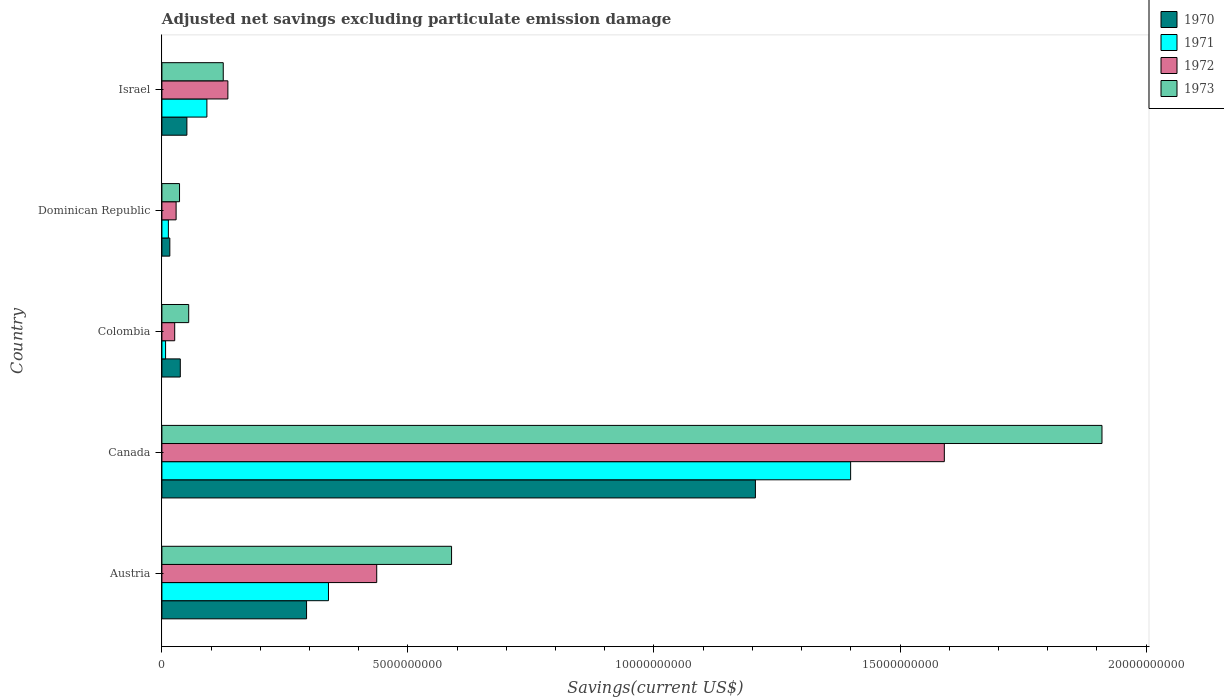Are the number of bars per tick equal to the number of legend labels?
Give a very brief answer. Yes. Are the number of bars on each tick of the Y-axis equal?
Offer a terse response. Yes. How many bars are there on the 5th tick from the top?
Provide a succinct answer. 4. What is the label of the 3rd group of bars from the top?
Offer a terse response. Colombia. What is the adjusted net savings in 1971 in Israel?
Offer a terse response. 9.14e+08. Across all countries, what is the maximum adjusted net savings in 1970?
Keep it short and to the point. 1.21e+1. Across all countries, what is the minimum adjusted net savings in 1970?
Your answer should be compact. 1.61e+08. What is the total adjusted net savings in 1971 in the graph?
Make the answer very short. 1.85e+1. What is the difference between the adjusted net savings in 1973 in Austria and that in Canada?
Make the answer very short. -1.32e+1. What is the difference between the adjusted net savings in 1970 in Colombia and the adjusted net savings in 1972 in Austria?
Your answer should be compact. -3.99e+09. What is the average adjusted net savings in 1970 per country?
Your response must be concise. 3.21e+09. What is the difference between the adjusted net savings in 1972 and adjusted net savings in 1971 in Israel?
Keep it short and to the point. 4.27e+08. In how many countries, is the adjusted net savings in 1972 greater than 12000000000 US$?
Provide a succinct answer. 1. What is the ratio of the adjusted net savings in 1972 in Dominican Republic to that in Israel?
Offer a very short reply. 0.22. Is the adjusted net savings in 1973 in Canada less than that in Israel?
Make the answer very short. No. Is the difference between the adjusted net savings in 1972 in Canada and Israel greater than the difference between the adjusted net savings in 1971 in Canada and Israel?
Provide a short and direct response. Yes. What is the difference between the highest and the second highest adjusted net savings in 1973?
Ensure brevity in your answer.  1.32e+1. What is the difference between the highest and the lowest adjusted net savings in 1973?
Offer a very short reply. 1.87e+1. In how many countries, is the adjusted net savings in 1970 greater than the average adjusted net savings in 1970 taken over all countries?
Offer a very short reply. 1. Is it the case that in every country, the sum of the adjusted net savings in 1971 and adjusted net savings in 1970 is greater than the sum of adjusted net savings in 1972 and adjusted net savings in 1973?
Your answer should be compact. No. What is the difference between two consecutive major ticks on the X-axis?
Your response must be concise. 5.00e+09. Does the graph contain any zero values?
Give a very brief answer. No. Where does the legend appear in the graph?
Provide a short and direct response. Top right. How are the legend labels stacked?
Offer a very short reply. Vertical. What is the title of the graph?
Provide a succinct answer. Adjusted net savings excluding particulate emission damage. What is the label or title of the X-axis?
Make the answer very short. Savings(current US$). What is the Savings(current US$) in 1970 in Austria?
Your answer should be very brief. 2.94e+09. What is the Savings(current US$) in 1971 in Austria?
Offer a terse response. 3.38e+09. What is the Savings(current US$) of 1972 in Austria?
Offer a terse response. 4.37e+09. What is the Savings(current US$) of 1973 in Austria?
Keep it short and to the point. 5.89e+09. What is the Savings(current US$) in 1970 in Canada?
Keep it short and to the point. 1.21e+1. What is the Savings(current US$) in 1971 in Canada?
Your answer should be compact. 1.40e+1. What is the Savings(current US$) in 1972 in Canada?
Ensure brevity in your answer.  1.59e+1. What is the Savings(current US$) of 1973 in Canada?
Give a very brief answer. 1.91e+1. What is the Savings(current US$) in 1970 in Colombia?
Make the answer very short. 3.74e+08. What is the Savings(current US$) in 1971 in Colombia?
Offer a terse response. 7.46e+07. What is the Savings(current US$) in 1972 in Colombia?
Ensure brevity in your answer.  2.60e+08. What is the Savings(current US$) of 1973 in Colombia?
Provide a short and direct response. 5.45e+08. What is the Savings(current US$) of 1970 in Dominican Republic?
Make the answer very short. 1.61e+08. What is the Savings(current US$) of 1971 in Dominican Republic?
Your answer should be very brief. 1.32e+08. What is the Savings(current US$) of 1972 in Dominican Republic?
Your answer should be compact. 2.89e+08. What is the Savings(current US$) of 1973 in Dominican Republic?
Your answer should be compact. 3.58e+08. What is the Savings(current US$) of 1970 in Israel?
Provide a short and direct response. 5.08e+08. What is the Savings(current US$) in 1971 in Israel?
Provide a succinct answer. 9.14e+08. What is the Savings(current US$) of 1972 in Israel?
Your response must be concise. 1.34e+09. What is the Savings(current US$) in 1973 in Israel?
Your response must be concise. 1.25e+09. Across all countries, what is the maximum Savings(current US$) in 1970?
Your answer should be compact. 1.21e+1. Across all countries, what is the maximum Savings(current US$) of 1971?
Your answer should be very brief. 1.40e+1. Across all countries, what is the maximum Savings(current US$) of 1972?
Your answer should be compact. 1.59e+1. Across all countries, what is the maximum Savings(current US$) of 1973?
Your response must be concise. 1.91e+1. Across all countries, what is the minimum Savings(current US$) of 1970?
Keep it short and to the point. 1.61e+08. Across all countries, what is the minimum Savings(current US$) of 1971?
Give a very brief answer. 7.46e+07. Across all countries, what is the minimum Savings(current US$) in 1972?
Offer a very short reply. 2.60e+08. Across all countries, what is the minimum Savings(current US$) in 1973?
Ensure brevity in your answer.  3.58e+08. What is the total Savings(current US$) in 1970 in the graph?
Keep it short and to the point. 1.60e+1. What is the total Savings(current US$) of 1971 in the graph?
Give a very brief answer. 1.85e+1. What is the total Savings(current US$) in 1972 in the graph?
Your answer should be very brief. 2.22e+1. What is the total Savings(current US$) in 1973 in the graph?
Offer a terse response. 2.71e+1. What is the difference between the Savings(current US$) in 1970 in Austria and that in Canada?
Offer a terse response. -9.12e+09. What is the difference between the Savings(current US$) in 1971 in Austria and that in Canada?
Your answer should be compact. -1.06e+1. What is the difference between the Savings(current US$) of 1972 in Austria and that in Canada?
Offer a very short reply. -1.15e+1. What is the difference between the Savings(current US$) of 1973 in Austria and that in Canada?
Give a very brief answer. -1.32e+1. What is the difference between the Savings(current US$) in 1970 in Austria and that in Colombia?
Your response must be concise. 2.57e+09. What is the difference between the Savings(current US$) of 1971 in Austria and that in Colombia?
Your answer should be very brief. 3.31e+09. What is the difference between the Savings(current US$) in 1972 in Austria and that in Colombia?
Offer a terse response. 4.11e+09. What is the difference between the Savings(current US$) in 1973 in Austria and that in Colombia?
Provide a short and direct response. 5.34e+09. What is the difference between the Savings(current US$) of 1970 in Austria and that in Dominican Republic?
Your answer should be very brief. 2.78e+09. What is the difference between the Savings(current US$) of 1971 in Austria and that in Dominican Republic?
Make the answer very short. 3.25e+09. What is the difference between the Savings(current US$) in 1972 in Austria and that in Dominican Republic?
Your answer should be compact. 4.08e+09. What is the difference between the Savings(current US$) of 1973 in Austria and that in Dominican Republic?
Make the answer very short. 5.53e+09. What is the difference between the Savings(current US$) of 1970 in Austria and that in Israel?
Your answer should be very brief. 2.43e+09. What is the difference between the Savings(current US$) in 1971 in Austria and that in Israel?
Offer a terse response. 2.47e+09. What is the difference between the Savings(current US$) of 1972 in Austria and that in Israel?
Offer a terse response. 3.02e+09. What is the difference between the Savings(current US$) of 1973 in Austria and that in Israel?
Your answer should be compact. 4.64e+09. What is the difference between the Savings(current US$) of 1970 in Canada and that in Colombia?
Your answer should be very brief. 1.17e+1. What is the difference between the Savings(current US$) of 1971 in Canada and that in Colombia?
Provide a short and direct response. 1.39e+1. What is the difference between the Savings(current US$) in 1972 in Canada and that in Colombia?
Provide a short and direct response. 1.56e+1. What is the difference between the Savings(current US$) of 1973 in Canada and that in Colombia?
Keep it short and to the point. 1.86e+1. What is the difference between the Savings(current US$) of 1970 in Canada and that in Dominican Republic?
Provide a succinct answer. 1.19e+1. What is the difference between the Savings(current US$) of 1971 in Canada and that in Dominican Republic?
Provide a succinct answer. 1.39e+1. What is the difference between the Savings(current US$) of 1972 in Canada and that in Dominican Republic?
Your response must be concise. 1.56e+1. What is the difference between the Savings(current US$) of 1973 in Canada and that in Dominican Republic?
Ensure brevity in your answer.  1.87e+1. What is the difference between the Savings(current US$) of 1970 in Canada and that in Israel?
Keep it short and to the point. 1.16e+1. What is the difference between the Savings(current US$) in 1971 in Canada and that in Israel?
Offer a very short reply. 1.31e+1. What is the difference between the Savings(current US$) of 1972 in Canada and that in Israel?
Ensure brevity in your answer.  1.46e+1. What is the difference between the Savings(current US$) of 1973 in Canada and that in Israel?
Offer a terse response. 1.79e+1. What is the difference between the Savings(current US$) of 1970 in Colombia and that in Dominican Republic?
Make the answer very short. 2.13e+08. What is the difference between the Savings(current US$) of 1971 in Colombia and that in Dominican Republic?
Offer a very short reply. -5.69e+07. What is the difference between the Savings(current US$) in 1972 in Colombia and that in Dominican Republic?
Keep it short and to the point. -2.84e+07. What is the difference between the Savings(current US$) in 1973 in Colombia and that in Dominican Republic?
Ensure brevity in your answer.  1.87e+08. What is the difference between the Savings(current US$) of 1970 in Colombia and that in Israel?
Provide a succinct answer. -1.34e+08. What is the difference between the Savings(current US$) in 1971 in Colombia and that in Israel?
Give a very brief answer. -8.40e+08. What is the difference between the Savings(current US$) of 1972 in Colombia and that in Israel?
Keep it short and to the point. -1.08e+09. What is the difference between the Savings(current US$) of 1973 in Colombia and that in Israel?
Keep it short and to the point. -7.02e+08. What is the difference between the Savings(current US$) in 1970 in Dominican Republic and that in Israel?
Your answer should be very brief. -3.47e+08. What is the difference between the Savings(current US$) in 1971 in Dominican Republic and that in Israel?
Give a very brief answer. -7.83e+08. What is the difference between the Savings(current US$) in 1972 in Dominican Republic and that in Israel?
Keep it short and to the point. -1.05e+09. What is the difference between the Savings(current US$) in 1973 in Dominican Republic and that in Israel?
Your response must be concise. -8.89e+08. What is the difference between the Savings(current US$) of 1970 in Austria and the Savings(current US$) of 1971 in Canada?
Keep it short and to the point. -1.11e+1. What is the difference between the Savings(current US$) of 1970 in Austria and the Savings(current US$) of 1972 in Canada?
Your response must be concise. -1.30e+1. What is the difference between the Savings(current US$) of 1970 in Austria and the Savings(current US$) of 1973 in Canada?
Give a very brief answer. -1.62e+1. What is the difference between the Savings(current US$) of 1971 in Austria and the Savings(current US$) of 1972 in Canada?
Your answer should be very brief. -1.25e+1. What is the difference between the Savings(current US$) in 1971 in Austria and the Savings(current US$) in 1973 in Canada?
Your answer should be compact. -1.57e+1. What is the difference between the Savings(current US$) of 1972 in Austria and the Savings(current US$) of 1973 in Canada?
Give a very brief answer. -1.47e+1. What is the difference between the Savings(current US$) of 1970 in Austria and the Savings(current US$) of 1971 in Colombia?
Ensure brevity in your answer.  2.87e+09. What is the difference between the Savings(current US$) in 1970 in Austria and the Savings(current US$) in 1972 in Colombia?
Provide a succinct answer. 2.68e+09. What is the difference between the Savings(current US$) in 1970 in Austria and the Savings(current US$) in 1973 in Colombia?
Your answer should be compact. 2.40e+09. What is the difference between the Savings(current US$) in 1971 in Austria and the Savings(current US$) in 1972 in Colombia?
Ensure brevity in your answer.  3.12e+09. What is the difference between the Savings(current US$) in 1971 in Austria and the Savings(current US$) in 1973 in Colombia?
Your response must be concise. 2.84e+09. What is the difference between the Savings(current US$) of 1972 in Austria and the Savings(current US$) of 1973 in Colombia?
Your answer should be compact. 3.82e+09. What is the difference between the Savings(current US$) of 1970 in Austria and the Savings(current US$) of 1971 in Dominican Republic?
Keep it short and to the point. 2.81e+09. What is the difference between the Savings(current US$) in 1970 in Austria and the Savings(current US$) in 1972 in Dominican Republic?
Keep it short and to the point. 2.65e+09. What is the difference between the Savings(current US$) of 1970 in Austria and the Savings(current US$) of 1973 in Dominican Republic?
Your answer should be compact. 2.58e+09. What is the difference between the Savings(current US$) of 1971 in Austria and the Savings(current US$) of 1972 in Dominican Republic?
Offer a very short reply. 3.10e+09. What is the difference between the Savings(current US$) of 1971 in Austria and the Savings(current US$) of 1973 in Dominican Republic?
Provide a succinct answer. 3.03e+09. What is the difference between the Savings(current US$) of 1972 in Austria and the Savings(current US$) of 1973 in Dominican Republic?
Your response must be concise. 4.01e+09. What is the difference between the Savings(current US$) of 1970 in Austria and the Savings(current US$) of 1971 in Israel?
Provide a short and direct response. 2.03e+09. What is the difference between the Savings(current US$) in 1970 in Austria and the Savings(current US$) in 1972 in Israel?
Your answer should be compact. 1.60e+09. What is the difference between the Savings(current US$) of 1970 in Austria and the Savings(current US$) of 1973 in Israel?
Your answer should be very brief. 1.69e+09. What is the difference between the Savings(current US$) of 1971 in Austria and the Savings(current US$) of 1972 in Israel?
Provide a succinct answer. 2.04e+09. What is the difference between the Savings(current US$) of 1971 in Austria and the Savings(current US$) of 1973 in Israel?
Ensure brevity in your answer.  2.14e+09. What is the difference between the Savings(current US$) of 1972 in Austria and the Savings(current US$) of 1973 in Israel?
Provide a succinct answer. 3.12e+09. What is the difference between the Savings(current US$) in 1970 in Canada and the Savings(current US$) in 1971 in Colombia?
Ensure brevity in your answer.  1.20e+1. What is the difference between the Savings(current US$) in 1970 in Canada and the Savings(current US$) in 1972 in Colombia?
Make the answer very short. 1.18e+1. What is the difference between the Savings(current US$) of 1970 in Canada and the Savings(current US$) of 1973 in Colombia?
Your answer should be very brief. 1.15e+1. What is the difference between the Savings(current US$) in 1971 in Canada and the Savings(current US$) in 1972 in Colombia?
Your response must be concise. 1.37e+1. What is the difference between the Savings(current US$) in 1971 in Canada and the Savings(current US$) in 1973 in Colombia?
Offer a terse response. 1.35e+1. What is the difference between the Savings(current US$) in 1972 in Canada and the Savings(current US$) in 1973 in Colombia?
Keep it short and to the point. 1.54e+1. What is the difference between the Savings(current US$) in 1970 in Canada and the Savings(current US$) in 1971 in Dominican Republic?
Your answer should be compact. 1.19e+1. What is the difference between the Savings(current US$) in 1970 in Canada and the Savings(current US$) in 1972 in Dominican Republic?
Your answer should be compact. 1.18e+1. What is the difference between the Savings(current US$) in 1970 in Canada and the Savings(current US$) in 1973 in Dominican Republic?
Your answer should be compact. 1.17e+1. What is the difference between the Savings(current US$) of 1971 in Canada and the Savings(current US$) of 1972 in Dominican Republic?
Give a very brief answer. 1.37e+1. What is the difference between the Savings(current US$) of 1971 in Canada and the Savings(current US$) of 1973 in Dominican Republic?
Offer a terse response. 1.36e+1. What is the difference between the Savings(current US$) of 1972 in Canada and the Savings(current US$) of 1973 in Dominican Republic?
Provide a short and direct response. 1.55e+1. What is the difference between the Savings(current US$) of 1970 in Canada and the Savings(current US$) of 1971 in Israel?
Make the answer very short. 1.11e+1. What is the difference between the Savings(current US$) of 1970 in Canada and the Savings(current US$) of 1972 in Israel?
Your answer should be compact. 1.07e+1. What is the difference between the Savings(current US$) of 1970 in Canada and the Savings(current US$) of 1973 in Israel?
Your answer should be compact. 1.08e+1. What is the difference between the Savings(current US$) of 1971 in Canada and the Savings(current US$) of 1972 in Israel?
Your response must be concise. 1.27e+1. What is the difference between the Savings(current US$) of 1971 in Canada and the Savings(current US$) of 1973 in Israel?
Ensure brevity in your answer.  1.27e+1. What is the difference between the Savings(current US$) in 1972 in Canada and the Savings(current US$) in 1973 in Israel?
Your answer should be compact. 1.47e+1. What is the difference between the Savings(current US$) of 1970 in Colombia and the Savings(current US$) of 1971 in Dominican Republic?
Provide a short and direct response. 2.42e+08. What is the difference between the Savings(current US$) in 1970 in Colombia and the Savings(current US$) in 1972 in Dominican Republic?
Your response must be concise. 8.52e+07. What is the difference between the Savings(current US$) of 1970 in Colombia and the Savings(current US$) of 1973 in Dominican Republic?
Make the answer very short. 1.57e+07. What is the difference between the Savings(current US$) in 1971 in Colombia and the Savings(current US$) in 1972 in Dominican Republic?
Offer a terse response. -2.14e+08. What is the difference between the Savings(current US$) in 1971 in Colombia and the Savings(current US$) in 1973 in Dominican Republic?
Make the answer very short. -2.84e+08. What is the difference between the Savings(current US$) in 1972 in Colombia and the Savings(current US$) in 1973 in Dominican Republic?
Your answer should be compact. -9.79e+07. What is the difference between the Savings(current US$) in 1970 in Colombia and the Savings(current US$) in 1971 in Israel?
Offer a terse response. -5.40e+08. What is the difference between the Savings(current US$) of 1970 in Colombia and the Savings(current US$) of 1972 in Israel?
Make the answer very short. -9.67e+08. What is the difference between the Savings(current US$) of 1970 in Colombia and the Savings(current US$) of 1973 in Israel?
Give a very brief answer. -8.73e+08. What is the difference between the Savings(current US$) of 1971 in Colombia and the Savings(current US$) of 1972 in Israel?
Make the answer very short. -1.27e+09. What is the difference between the Savings(current US$) of 1971 in Colombia and the Savings(current US$) of 1973 in Israel?
Provide a short and direct response. -1.17e+09. What is the difference between the Savings(current US$) in 1972 in Colombia and the Savings(current US$) in 1973 in Israel?
Your response must be concise. -9.87e+08. What is the difference between the Savings(current US$) in 1970 in Dominican Republic and the Savings(current US$) in 1971 in Israel?
Offer a very short reply. -7.53e+08. What is the difference between the Savings(current US$) in 1970 in Dominican Republic and the Savings(current US$) in 1972 in Israel?
Your answer should be compact. -1.18e+09. What is the difference between the Savings(current US$) of 1970 in Dominican Republic and the Savings(current US$) of 1973 in Israel?
Provide a short and direct response. -1.09e+09. What is the difference between the Savings(current US$) in 1971 in Dominican Republic and the Savings(current US$) in 1972 in Israel?
Provide a succinct answer. -1.21e+09. What is the difference between the Savings(current US$) in 1971 in Dominican Republic and the Savings(current US$) in 1973 in Israel?
Provide a succinct answer. -1.12e+09. What is the difference between the Savings(current US$) in 1972 in Dominican Republic and the Savings(current US$) in 1973 in Israel?
Provide a short and direct response. -9.58e+08. What is the average Savings(current US$) of 1970 per country?
Offer a terse response. 3.21e+09. What is the average Savings(current US$) in 1971 per country?
Keep it short and to the point. 3.70e+09. What is the average Savings(current US$) of 1972 per country?
Your answer should be compact. 4.43e+09. What is the average Savings(current US$) of 1973 per country?
Ensure brevity in your answer.  5.43e+09. What is the difference between the Savings(current US$) of 1970 and Savings(current US$) of 1971 in Austria?
Keep it short and to the point. -4.45e+08. What is the difference between the Savings(current US$) in 1970 and Savings(current US$) in 1972 in Austria?
Give a very brief answer. -1.43e+09. What is the difference between the Savings(current US$) of 1970 and Savings(current US$) of 1973 in Austria?
Ensure brevity in your answer.  -2.95e+09. What is the difference between the Savings(current US$) in 1971 and Savings(current US$) in 1972 in Austria?
Give a very brief answer. -9.81e+08. What is the difference between the Savings(current US$) in 1971 and Savings(current US$) in 1973 in Austria?
Your answer should be very brief. -2.50e+09. What is the difference between the Savings(current US$) of 1972 and Savings(current US$) of 1973 in Austria?
Your response must be concise. -1.52e+09. What is the difference between the Savings(current US$) in 1970 and Savings(current US$) in 1971 in Canada?
Your answer should be very brief. -1.94e+09. What is the difference between the Savings(current US$) of 1970 and Savings(current US$) of 1972 in Canada?
Provide a succinct answer. -3.84e+09. What is the difference between the Savings(current US$) in 1970 and Savings(current US$) in 1973 in Canada?
Give a very brief answer. -7.04e+09. What is the difference between the Savings(current US$) in 1971 and Savings(current US$) in 1972 in Canada?
Provide a short and direct response. -1.90e+09. What is the difference between the Savings(current US$) in 1971 and Savings(current US$) in 1973 in Canada?
Give a very brief answer. -5.11e+09. What is the difference between the Savings(current US$) in 1972 and Savings(current US$) in 1973 in Canada?
Provide a short and direct response. -3.20e+09. What is the difference between the Savings(current US$) of 1970 and Savings(current US$) of 1971 in Colombia?
Provide a succinct answer. 2.99e+08. What is the difference between the Savings(current US$) of 1970 and Savings(current US$) of 1972 in Colombia?
Provide a short and direct response. 1.14e+08. What is the difference between the Savings(current US$) in 1970 and Savings(current US$) in 1973 in Colombia?
Make the answer very short. -1.71e+08. What is the difference between the Savings(current US$) in 1971 and Savings(current US$) in 1972 in Colombia?
Give a very brief answer. -1.86e+08. What is the difference between the Savings(current US$) in 1971 and Savings(current US$) in 1973 in Colombia?
Keep it short and to the point. -4.70e+08. What is the difference between the Savings(current US$) in 1972 and Savings(current US$) in 1973 in Colombia?
Provide a short and direct response. -2.85e+08. What is the difference between the Savings(current US$) of 1970 and Savings(current US$) of 1971 in Dominican Republic?
Your response must be concise. 2.96e+07. What is the difference between the Savings(current US$) in 1970 and Savings(current US$) in 1972 in Dominican Republic?
Give a very brief answer. -1.28e+08. What is the difference between the Savings(current US$) in 1970 and Savings(current US$) in 1973 in Dominican Republic?
Give a very brief answer. -1.97e+08. What is the difference between the Savings(current US$) in 1971 and Savings(current US$) in 1972 in Dominican Republic?
Your answer should be very brief. -1.57e+08. What is the difference between the Savings(current US$) of 1971 and Savings(current US$) of 1973 in Dominican Republic?
Provide a short and direct response. -2.27e+08. What is the difference between the Savings(current US$) in 1972 and Savings(current US$) in 1973 in Dominican Republic?
Make the answer very short. -6.95e+07. What is the difference between the Savings(current US$) of 1970 and Savings(current US$) of 1971 in Israel?
Provide a short and direct response. -4.06e+08. What is the difference between the Savings(current US$) of 1970 and Savings(current US$) of 1972 in Israel?
Offer a very short reply. -8.33e+08. What is the difference between the Savings(current US$) in 1970 and Savings(current US$) in 1973 in Israel?
Offer a very short reply. -7.39e+08. What is the difference between the Savings(current US$) of 1971 and Savings(current US$) of 1972 in Israel?
Provide a short and direct response. -4.27e+08. What is the difference between the Savings(current US$) of 1971 and Savings(current US$) of 1973 in Israel?
Give a very brief answer. -3.33e+08. What is the difference between the Savings(current US$) of 1972 and Savings(current US$) of 1973 in Israel?
Make the answer very short. 9.40e+07. What is the ratio of the Savings(current US$) of 1970 in Austria to that in Canada?
Your answer should be compact. 0.24. What is the ratio of the Savings(current US$) in 1971 in Austria to that in Canada?
Give a very brief answer. 0.24. What is the ratio of the Savings(current US$) of 1972 in Austria to that in Canada?
Ensure brevity in your answer.  0.27. What is the ratio of the Savings(current US$) of 1973 in Austria to that in Canada?
Provide a short and direct response. 0.31. What is the ratio of the Savings(current US$) in 1970 in Austria to that in Colombia?
Your response must be concise. 7.86. What is the ratio of the Savings(current US$) in 1971 in Austria to that in Colombia?
Keep it short and to the point. 45.37. What is the ratio of the Savings(current US$) in 1972 in Austria to that in Colombia?
Your answer should be very brief. 16.77. What is the ratio of the Savings(current US$) of 1973 in Austria to that in Colombia?
Your response must be concise. 10.8. What is the ratio of the Savings(current US$) in 1970 in Austria to that in Dominican Republic?
Your answer should be compact. 18.25. What is the ratio of the Savings(current US$) in 1971 in Austria to that in Dominican Republic?
Your response must be concise. 25.73. What is the ratio of the Savings(current US$) of 1972 in Austria to that in Dominican Republic?
Your response must be concise. 15.12. What is the ratio of the Savings(current US$) of 1973 in Austria to that in Dominican Republic?
Provide a short and direct response. 16.43. What is the ratio of the Savings(current US$) in 1970 in Austria to that in Israel?
Offer a terse response. 5.79. What is the ratio of the Savings(current US$) of 1971 in Austria to that in Israel?
Your answer should be compact. 3.7. What is the ratio of the Savings(current US$) in 1972 in Austria to that in Israel?
Provide a succinct answer. 3.26. What is the ratio of the Savings(current US$) in 1973 in Austria to that in Israel?
Your answer should be compact. 4.72. What is the ratio of the Savings(current US$) in 1970 in Canada to that in Colombia?
Ensure brevity in your answer.  32.26. What is the ratio of the Savings(current US$) of 1971 in Canada to that in Colombia?
Provide a succinct answer. 187.59. What is the ratio of the Savings(current US$) in 1972 in Canada to that in Colombia?
Offer a terse response. 61.09. What is the ratio of the Savings(current US$) of 1973 in Canada to that in Colombia?
Your answer should be very brief. 35.07. What is the ratio of the Savings(current US$) of 1970 in Canada to that in Dominican Republic?
Your answer should be compact. 74.87. What is the ratio of the Savings(current US$) in 1971 in Canada to that in Dominican Republic?
Give a very brief answer. 106.4. What is the ratio of the Savings(current US$) in 1972 in Canada to that in Dominican Republic?
Offer a terse response. 55.08. What is the ratio of the Savings(current US$) of 1973 in Canada to that in Dominican Republic?
Offer a terse response. 53.33. What is the ratio of the Savings(current US$) in 1970 in Canada to that in Israel?
Provide a succinct answer. 23.75. What is the ratio of the Savings(current US$) of 1971 in Canada to that in Israel?
Offer a terse response. 15.31. What is the ratio of the Savings(current US$) of 1972 in Canada to that in Israel?
Offer a terse response. 11.86. What is the ratio of the Savings(current US$) of 1973 in Canada to that in Israel?
Keep it short and to the point. 15.32. What is the ratio of the Savings(current US$) in 1970 in Colombia to that in Dominican Republic?
Make the answer very short. 2.32. What is the ratio of the Savings(current US$) of 1971 in Colombia to that in Dominican Republic?
Offer a very short reply. 0.57. What is the ratio of the Savings(current US$) of 1972 in Colombia to that in Dominican Republic?
Your answer should be very brief. 0.9. What is the ratio of the Savings(current US$) of 1973 in Colombia to that in Dominican Republic?
Give a very brief answer. 1.52. What is the ratio of the Savings(current US$) of 1970 in Colombia to that in Israel?
Provide a short and direct response. 0.74. What is the ratio of the Savings(current US$) in 1971 in Colombia to that in Israel?
Offer a terse response. 0.08. What is the ratio of the Savings(current US$) in 1972 in Colombia to that in Israel?
Provide a succinct answer. 0.19. What is the ratio of the Savings(current US$) in 1973 in Colombia to that in Israel?
Offer a terse response. 0.44. What is the ratio of the Savings(current US$) of 1970 in Dominican Republic to that in Israel?
Your answer should be compact. 0.32. What is the ratio of the Savings(current US$) of 1971 in Dominican Republic to that in Israel?
Offer a very short reply. 0.14. What is the ratio of the Savings(current US$) of 1972 in Dominican Republic to that in Israel?
Provide a succinct answer. 0.22. What is the ratio of the Savings(current US$) in 1973 in Dominican Republic to that in Israel?
Your answer should be compact. 0.29. What is the difference between the highest and the second highest Savings(current US$) in 1970?
Provide a short and direct response. 9.12e+09. What is the difference between the highest and the second highest Savings(current US$) in 1971?
Ensure brevity in your answer.  1.06e+1. What is the difference between the highest and the second highest Savings(current US$) of 1972?
Ensure brevity in your answer.  1.15e+1. What is the difference between the highest and the second highest Savings(current US$) of 1973?
Your response must be concise. 1.32e+1. What is the difference between the highest and the lowest Savings(current US$) in 1970?
Keep it short and to the point. 1.19e+1. What is the difference between the highest and the lowest Savings(current US$) in 1971?
Ensure brevity in your answer.  1.39e+1. What is the difference between the highest and the lowest Savings(current US$) in 1972?
Your answer should be very brief. 1.56e+1. What is the difference between the highest and the lowest Savings(current US$) in 1973?
Give a very brief answer. 1.87e+1. 